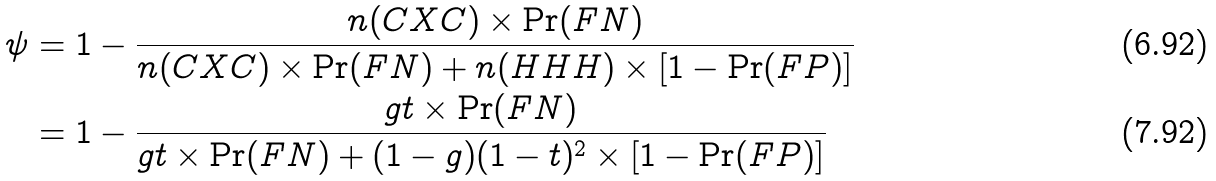<formula> <loc_0><loc_0><loc_500><loc_500>\psi & = 1 - \frac { n ( C X C ) \times \Pr ( F N ) } { n ( C X C ) \times \Pr ( F N ) + n ( H H H ) \times \left [ 1 - \Pr ( F P ) \right ] } \\ & = 1 - \frac { g t \times \Pr ( F N ) } { g t \times \Pr ( F N ) + ( 1 - g ) ( 1 - t ) ^ { 2 } \times \left [ 1 - \Pr ( F P ) \right ] }</formula> 